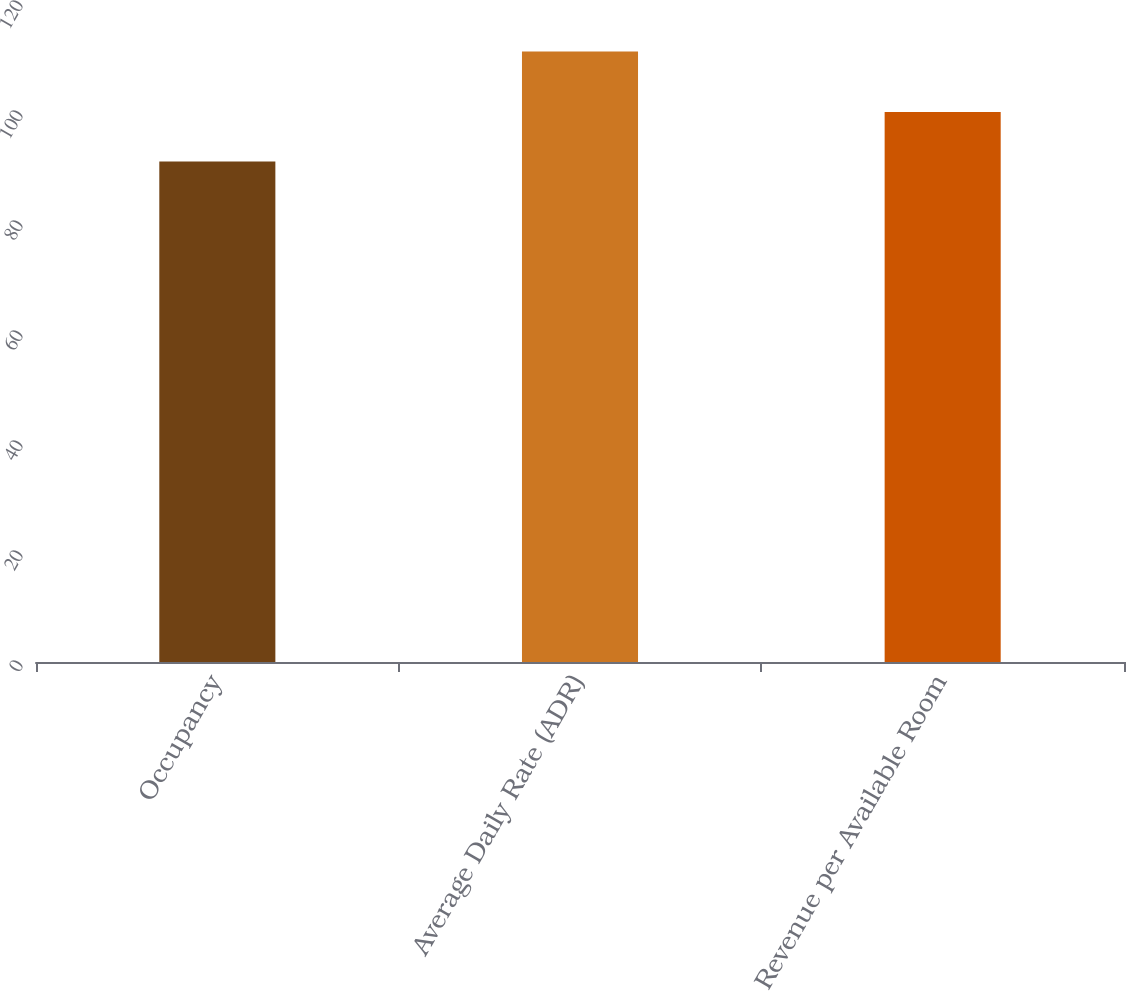<chart> <loc_0><loc_0><loc_500><loc_500><bar_chart><fcel>Occupancy<fcel>Average Daily Rate (ADR)<fcel>Revenue per Available Room<nl><fcel>91<fcel>111<fcel>100<nl></chart> 